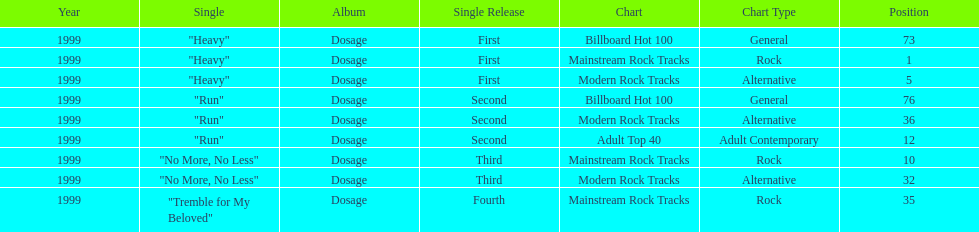How many singles from "dosage" appeared on the modern rock tracks charts? 3. 